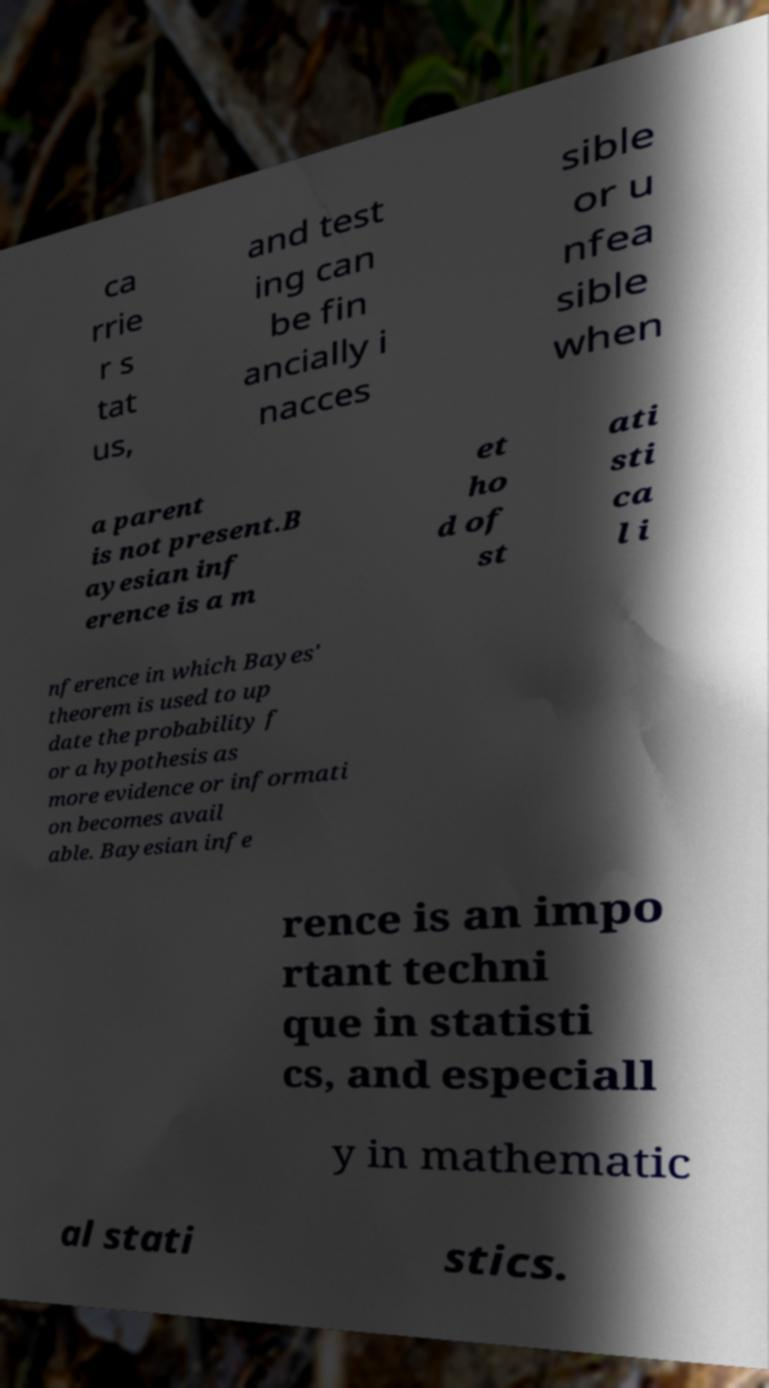Could you assist in decoding the text presented in this image and type it out clearly? ca rrie r s tat us, and test ing can be fin ancially i nacces sible or u nfea sible when a parent is not present.B ayesian inf erence is a m et ho d of st ati sti ca l i nference in which Bayes' theorem is used to up date the probability f or a hypothesis as more evidence or informati on becomes avail able. Bayesian infe rence is an impo rtant techni que in statisti cs, and especiall y in mathematic al stati stics. 